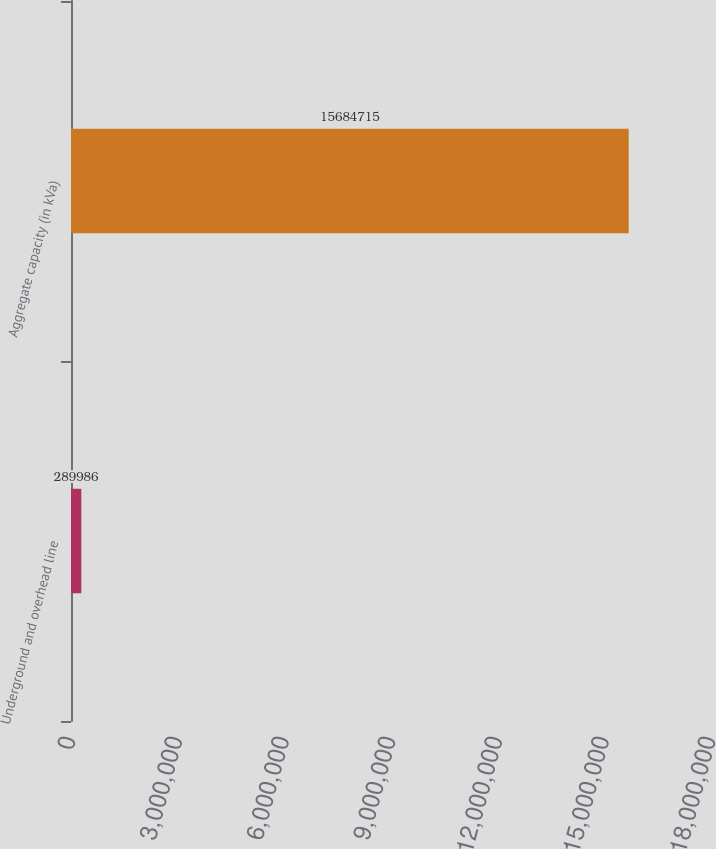Convert chart to OTSL. <chart><loc_0><loc_0><loc_500><loc_500><bar_chart><fcel>Underground and overhead line<fcel>Aggregate capacity (in kVa)<nl><fcel>289986<fcel>1.56847e+07<nl></chart> 